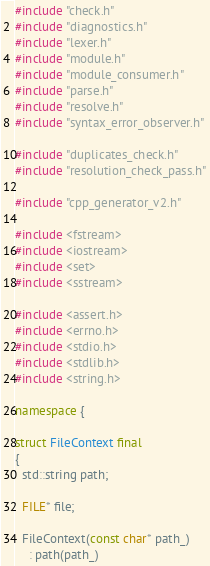<code> <loc_0><loc_0><loc_500><loc_500><_C++_>#include "check.h"
#include "diagnostics.h"
#include "lexer.h"
#include "module.h"
#include "module_consumer.h"
#include "parse.h"
#include "resolve.h"
#include "syntax_error_observer.h"

#include "duplicates_check.h"
#include "resolution_check_pass.h"

#include "cpp_generator_v2.h"

#include <fstream>
#include <iostream>
#include <set>
#include <sstream>

#include <assert.h>
#include <errno.h>
#include <stdio.h>
#include <stdlib.h>
#include <string.h>

namespace {

struct FileContext final
{
  std::string path;

  FILE* file;

  FileContext(const char* path_)
    : path(path_)</code> 